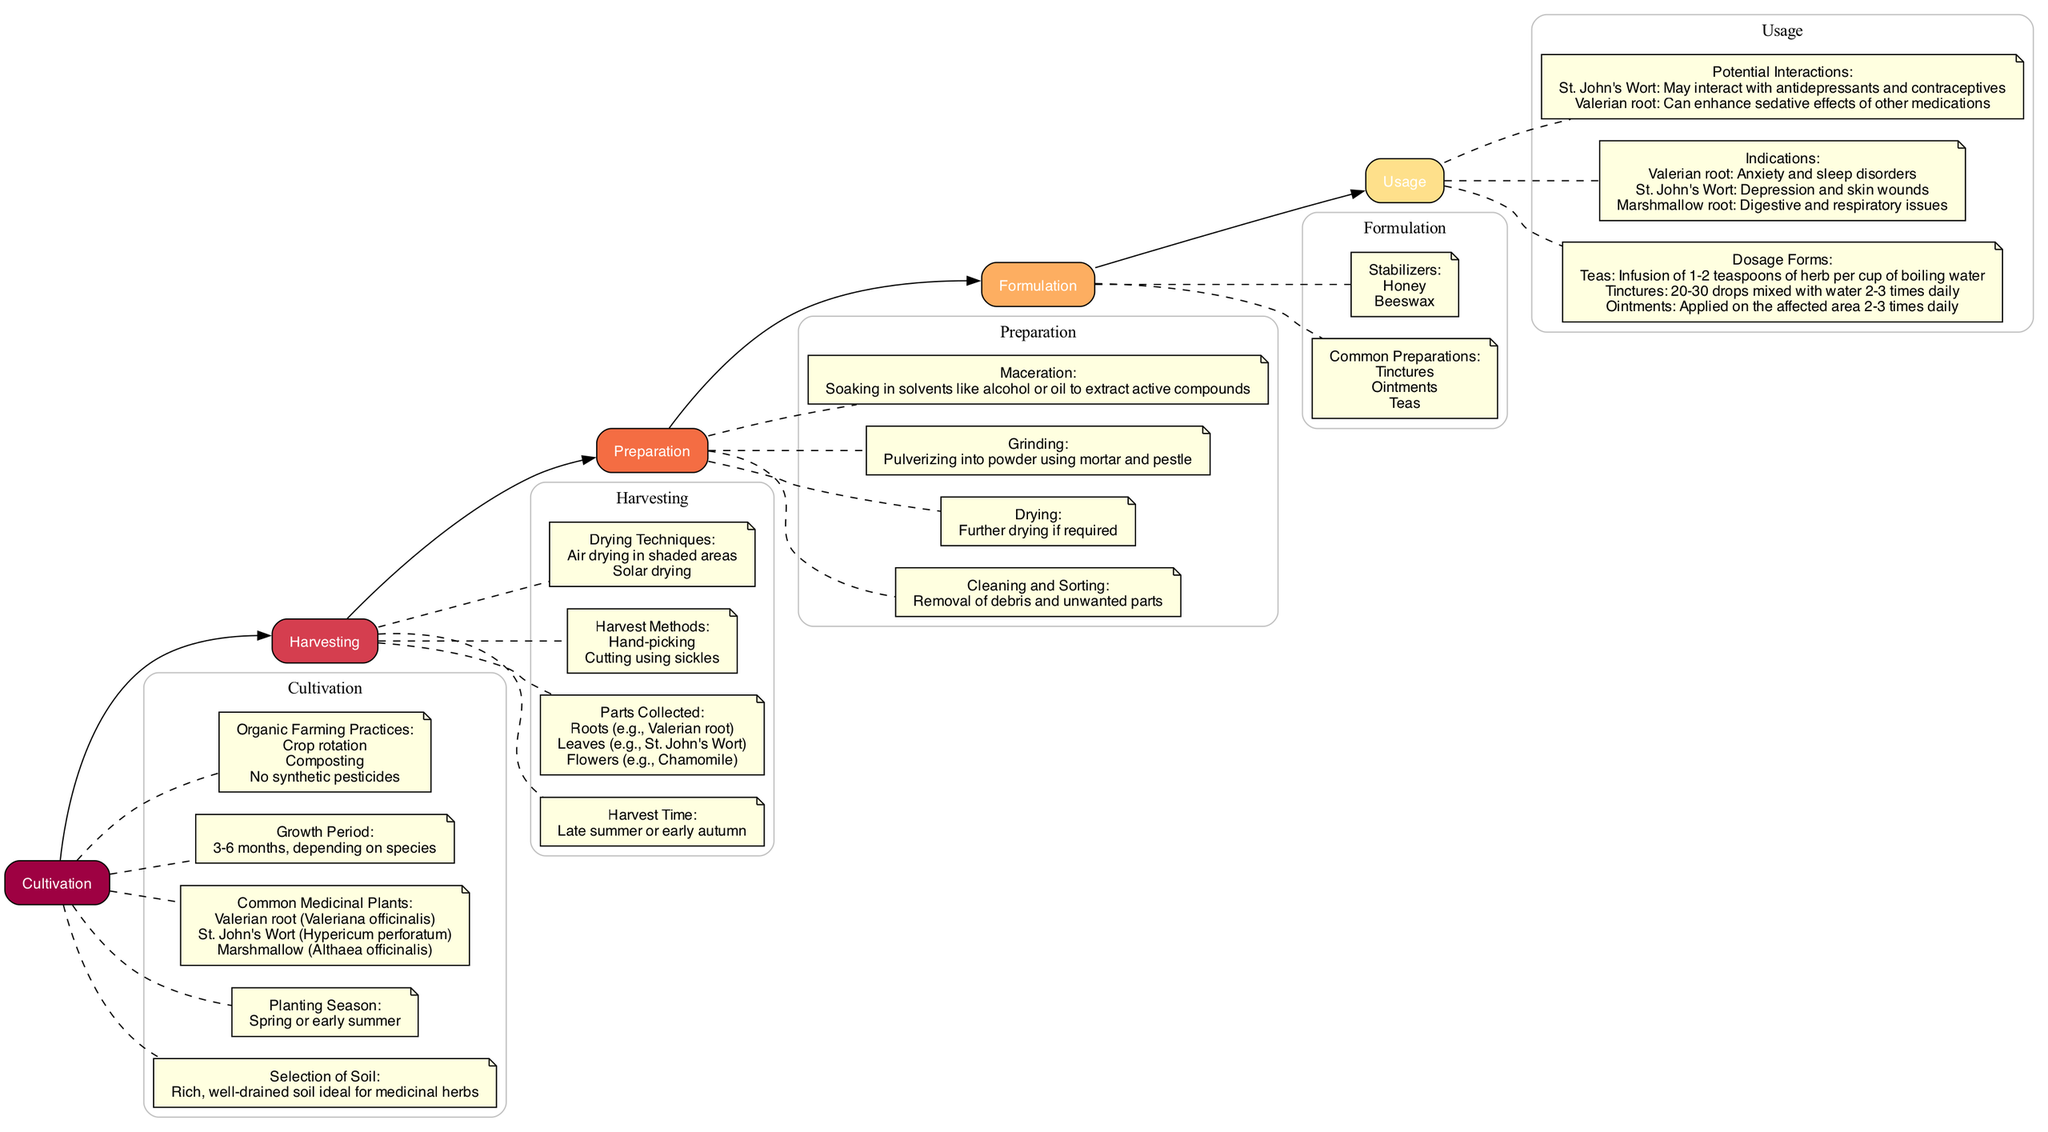What is the ideal soil type for cultivation? The diagram states that "Rich, well-drained soil ideal for medicinal herbs" is the selection criteria for soil in the cultivation stage.
Answer: Rich, well-drained soil How many common medicinal plants are mentioned? In the cultivation section, there are three specific medicinal plants listed: Valerian root, St. John's Wort, and Marshmallow. Hence, the total is three.
Answer: 3 What are the two harvesting methods? From the harvesting node, it lists "Hand-picking" and "Cutting using sickles" as the methods for harvesting. Therefore, two methods are specifically mentioned.
Answer: Hand-picking, Cutting using sickles What is one common preparation from the formulation stage? The formulation stage lists several common preparations, including "Tinctures", which I can identify directly from the section.
Answer: Tinctures What should be applied directly to the skin for 20-30 minutes? In the usage section, it specifies that "Poultices" are the form meant to be applied directly to the skin for this specified duration.
Answer: Poultices What is the growth period range for medicinal plants? According to the cultivation stage, it states that the growth period for the plants can vary from "3-6 months, depending on species".
Answer: 3-6 months What dosage form uses 20-30 drops mixed with water? The usage section indicates that "Tinctures" involve this dosage form, detailing its preparation and application.
Answer: Tinctures What is the main purpose of St. John's Wort? Under the usage section, it mentions that "St. John's Wort" is indicated for "Depression and skin wounds", thus serving this purpose.
Answer: Depression and skin wounds What drying technique is indicated for herbs after harvesting? The harvesting stage specifies "Air drying in shaded areas" as one technique for drying the collected herbs.
Answer: Air drying in shaded areas 